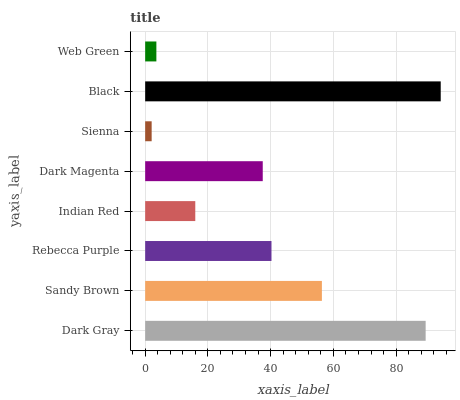Is Sienna the minimum?
Answer yes or no. Yes. Is Black the maximum?
Answer yes or no. Yes. Is Sandy Brown the minimum?
Answer yes or no. No. Is Sandy Brown the maximum?
Answer yes or no. No. Is Dark Gray greater than Sandy Brown?
Answer yes or no. Yes. Is Sandy Brown less than Dark Gray?
Answer yes or no. Yes. Is Sandy Brown greater than Dark Gray?
Answer yes or no. No. Is Dark Gray less than Sandy Brown?
Answer yes or no. No. Is Rebecca Purple the high median?
Answer yes or no. Yes. Is Dark Magenta the low median?
Answer yes or no. Yes. Is Dark Gray the high median?
Answer yes or no. No. Is Web Green the low median?
Answer yes or no. No. 